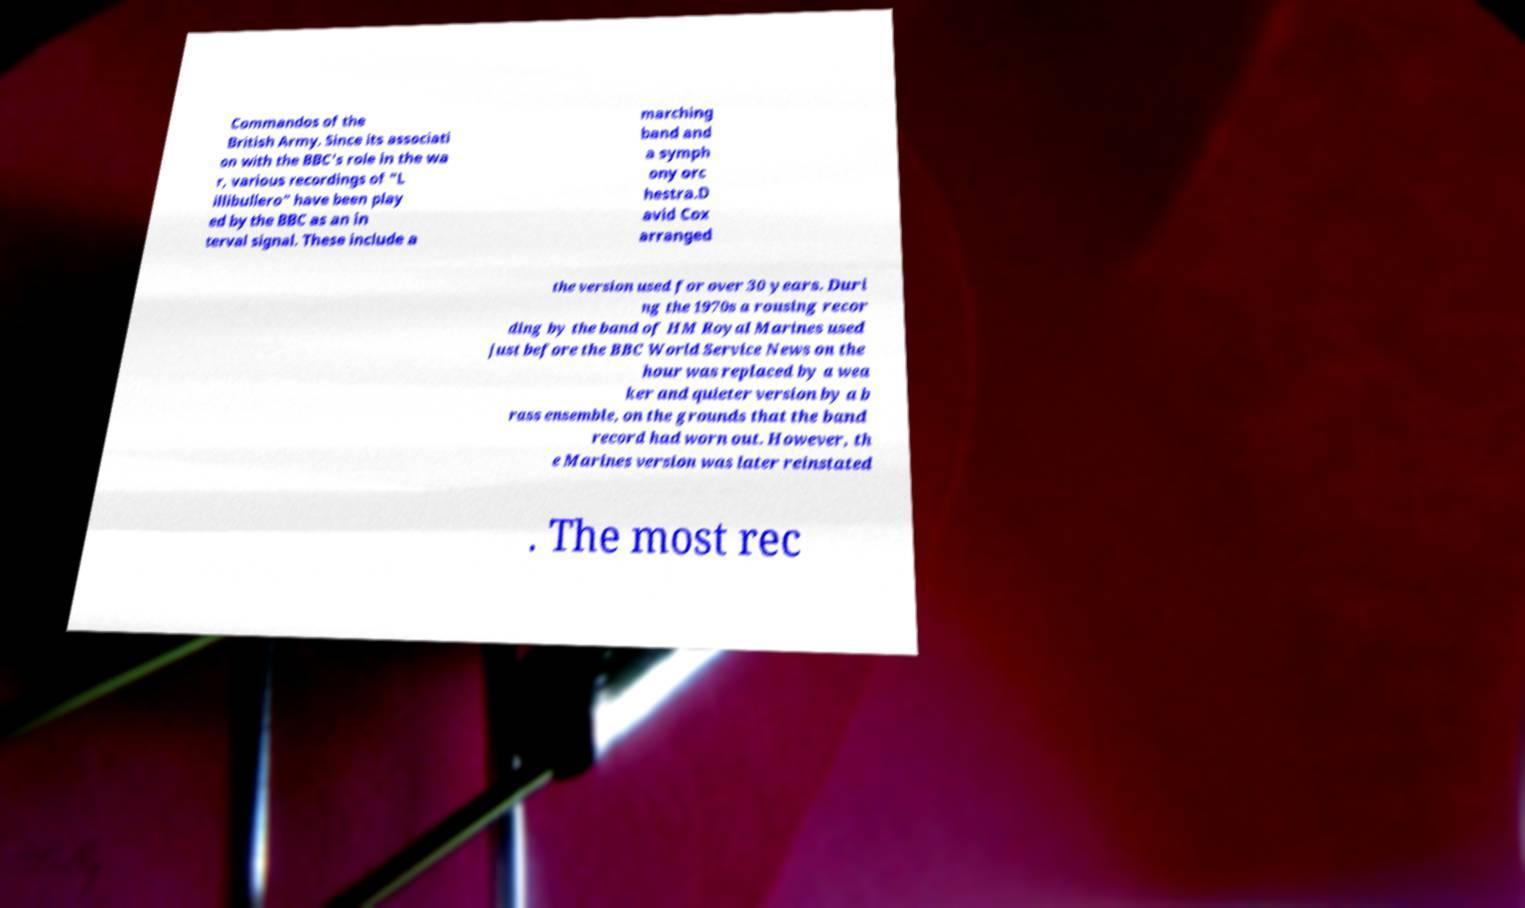I need the written content from this picture converted into text. Can you do that? Commandos of the British Army. Since its associati on with the BBC's role in the wa r, various recordings of "L illibullero" have been play ed by the BBC as an in terval signal. These include a marching band and a symph ony orc hestra.D avid Cox arranged the version used for over 30 years. Duri ng the 1970s a rousing recor ding by the band of HM Royal Marines used just before the BBC World Service News on the hour was replaced by a wea ker and quieter version by a b rass ensemble, on the grounds that the band record had worn out. However, th e Marines version was later reinstated . The most rec 